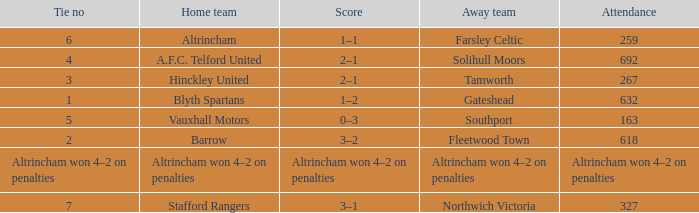What was the score when there were 7 ties? 3–1. 